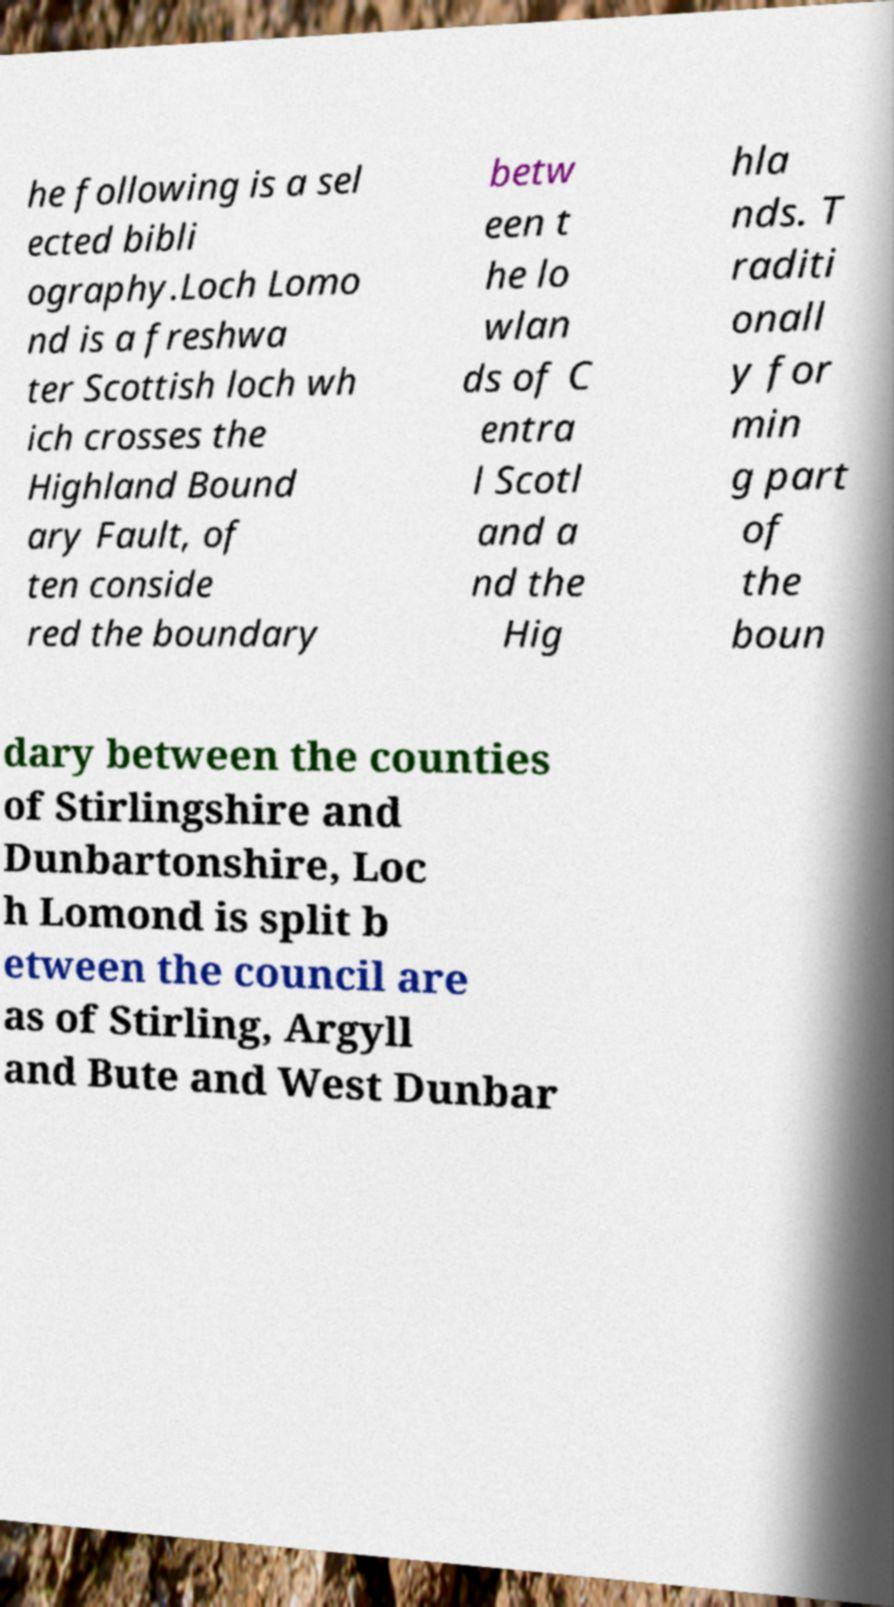For documentation purposes, I need the text within this image transcribed. Could you provide that? he following is a sel ected bibli ography.Loch Lomo nd is a freshwa ter Scottish loch wh ich crosses the Highland Bound ary Fault, of ten conside red the boundary betw een t he lo wlan ds of C entra l Scotl and a nd the Hig hla nds. T raditi onall y for min g part of the boun dary between the counties of Stirlingshire and Dunbartonshire, Loc h Lomond is split b etween the council are as of Stirling, Argyll and Bute and West Dunbar 